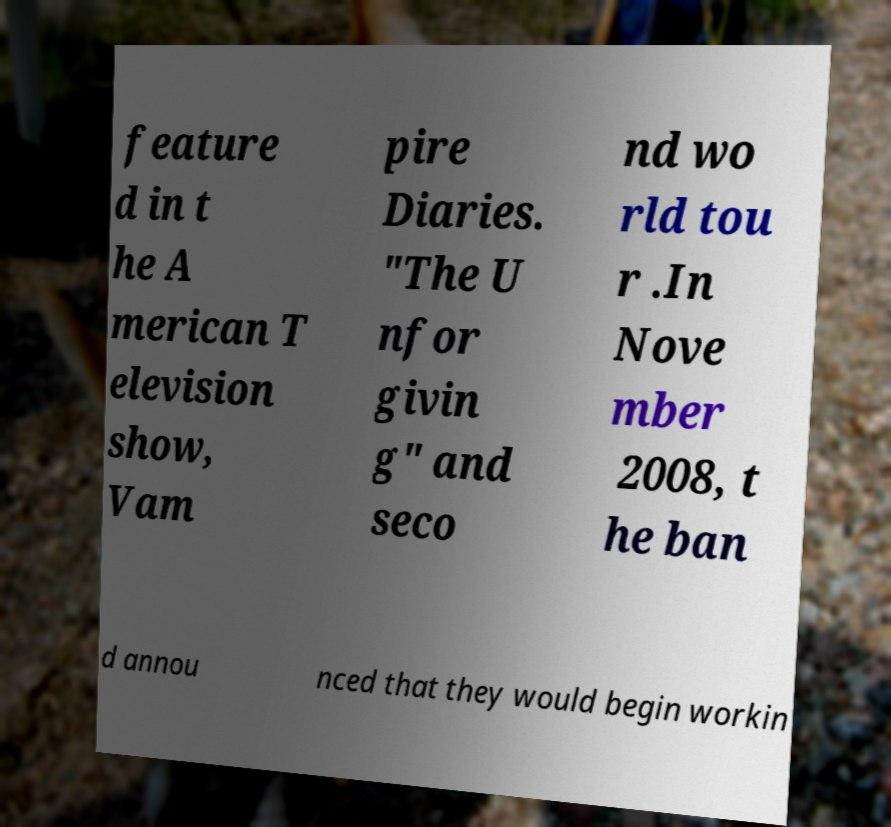Can you accurately transcribe the text from the provided image for me? feature d in t he A merican T elevision show, Vam pire Diaries. "The U nfor givin g" and seco nd wo rld tou r .In Nove mber 2008, t he ban d annou nced that they would begin workin 